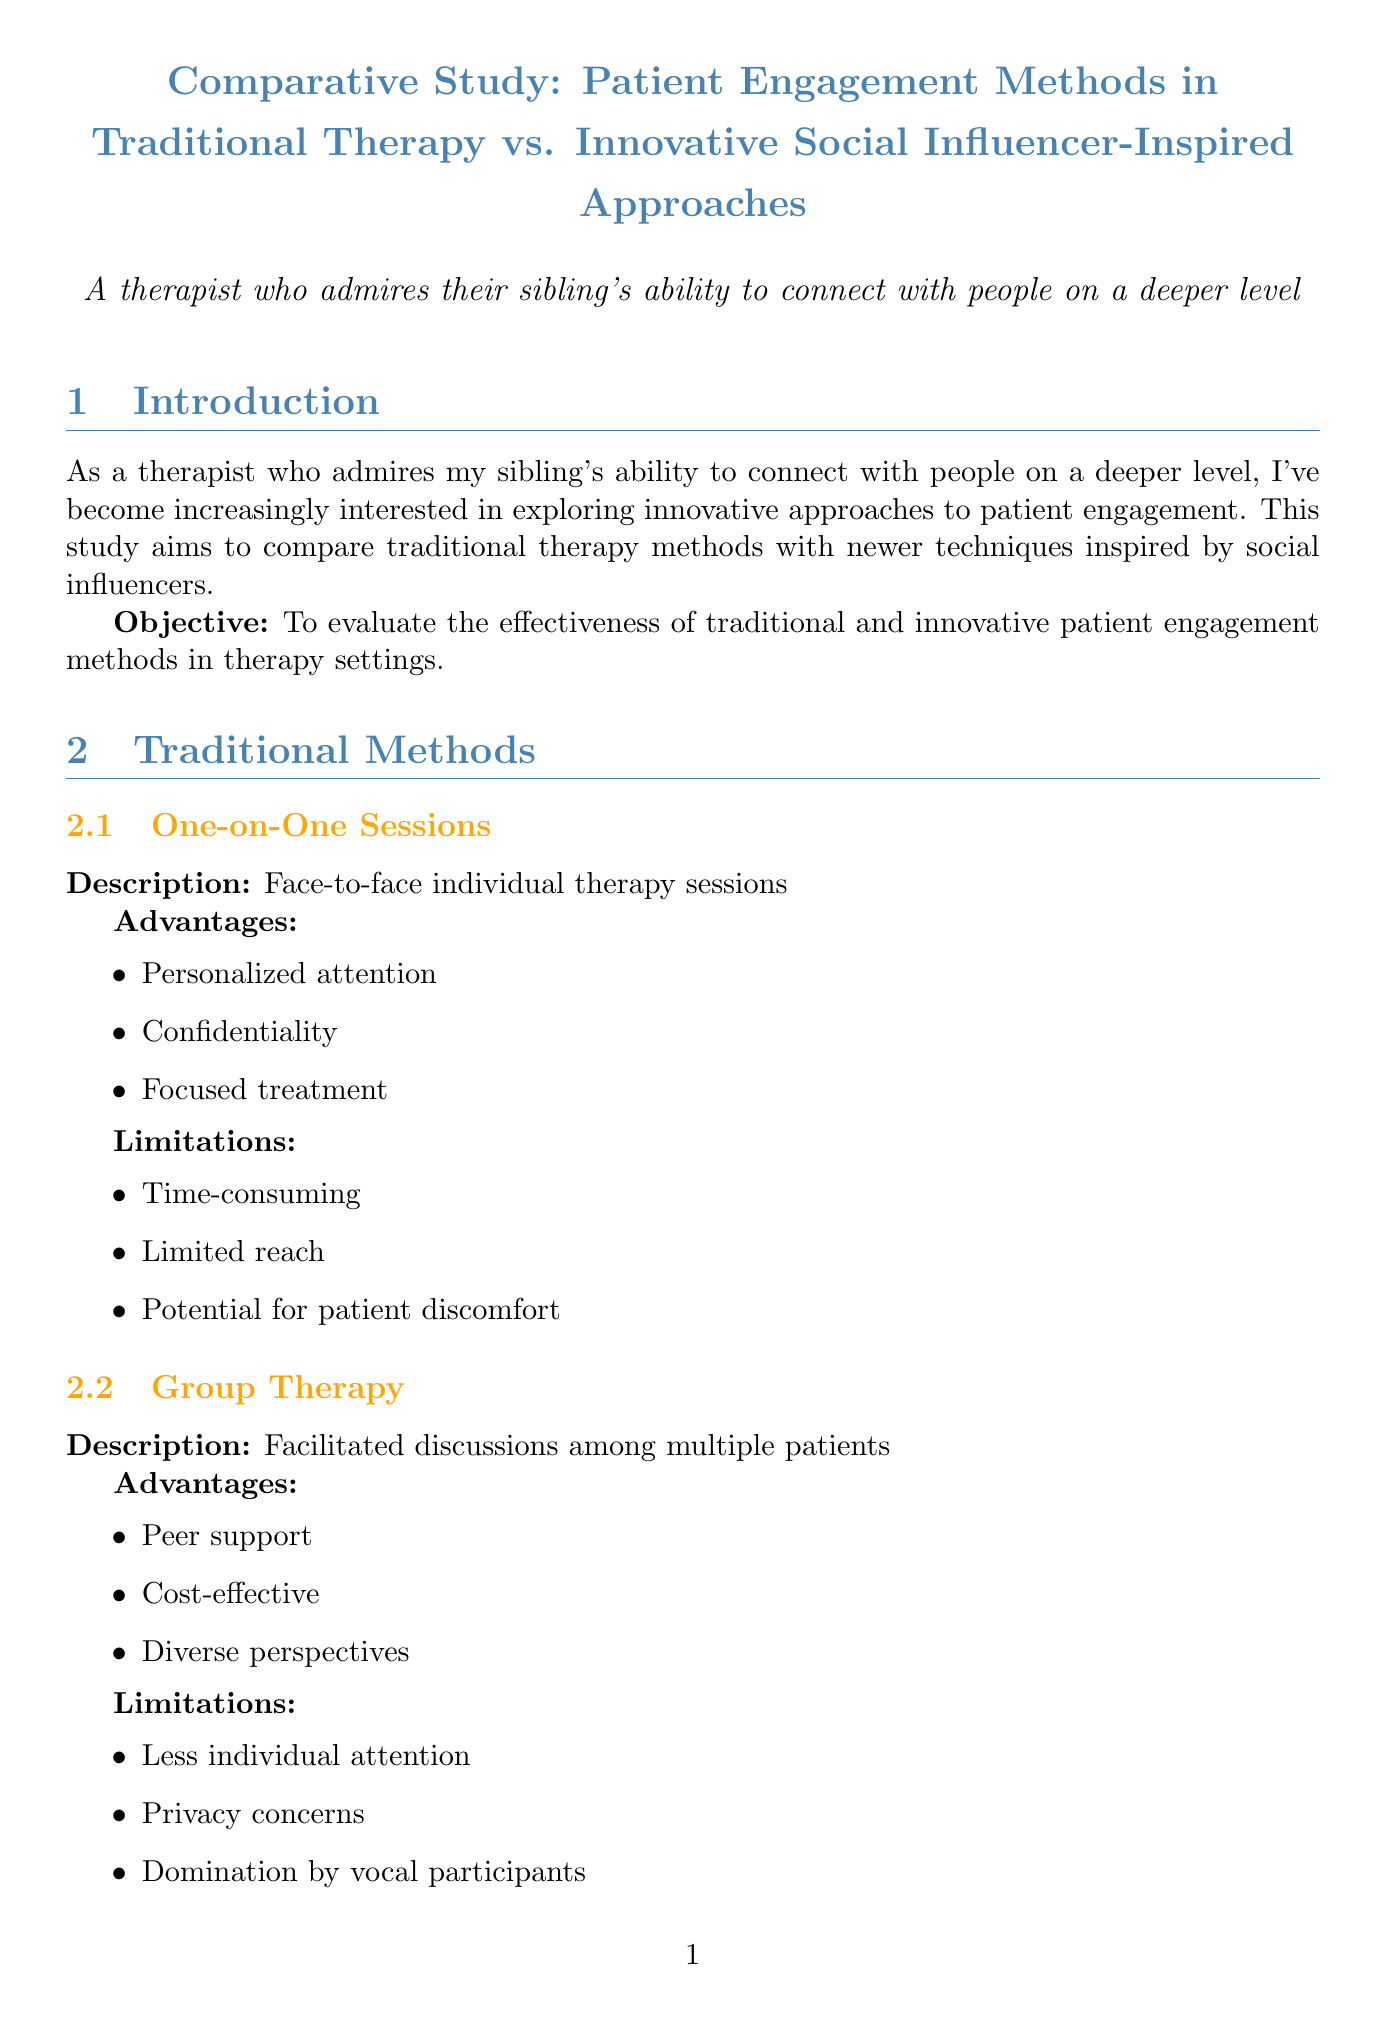what is the title of the study? The title is presented at the beginning of the document.
Answer: Comparative Study: Patient Engagement Methods in Traditional Therapy vs. Innovative Social Influencer-Inspired Approaches what are the advantages of one-on-one sessions? The advantages are listed in the section about traditional methods.
Answer: Personalized attention, Confidentiality, Focused treatment what is the average satisfaction score for innovative methods? The score is found in the patient satisfaction section of the document.
Answer: 8.7/10 average satisfaction score who is associated with the SuperBetter app? The example in the gamification section mentions this person.
Answer: Jane McGonigal what is the outcome for the traditional approach patient? The outcome is detailed in the case studies section.
Answer: Moderate improvement in anxiety symptoms after 6 months of treatment how much was the average reduction in symptoms using innovative approaches? This information is provided in the treatment outcomes section.
Answer: 40% average reduction in reported symptoms what future direction is suggested for this field? Future directions are listed towards the end of the document.
Answer: Integrate social media strategies into traditional therapy what is the engagement rate for daily app usage in innovative methods? The engagement rate is mentioned in the comparative analysis section.
Answer: 85% engagement rate 